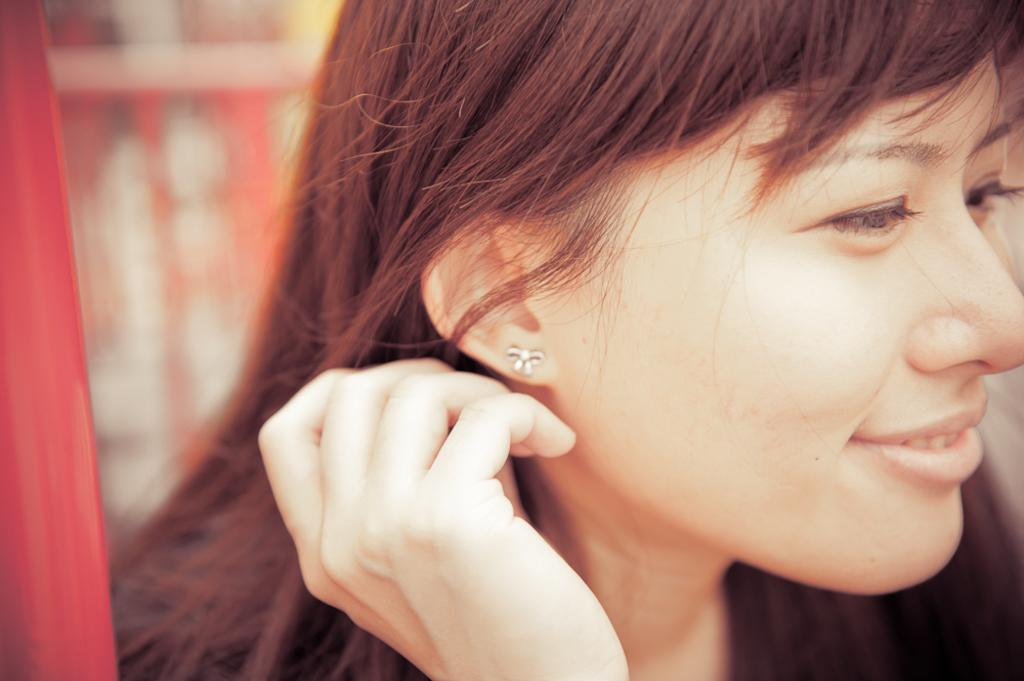What is the main subject of the image? There is a person in the image. Can you describe the background of the image? The background of the image is blurred. How many beds are visible in the image? There are no beds present in the image. What type of ornament is hanging from the ceiling in the image? There is no ornament hanging from the ceiling in the image. 